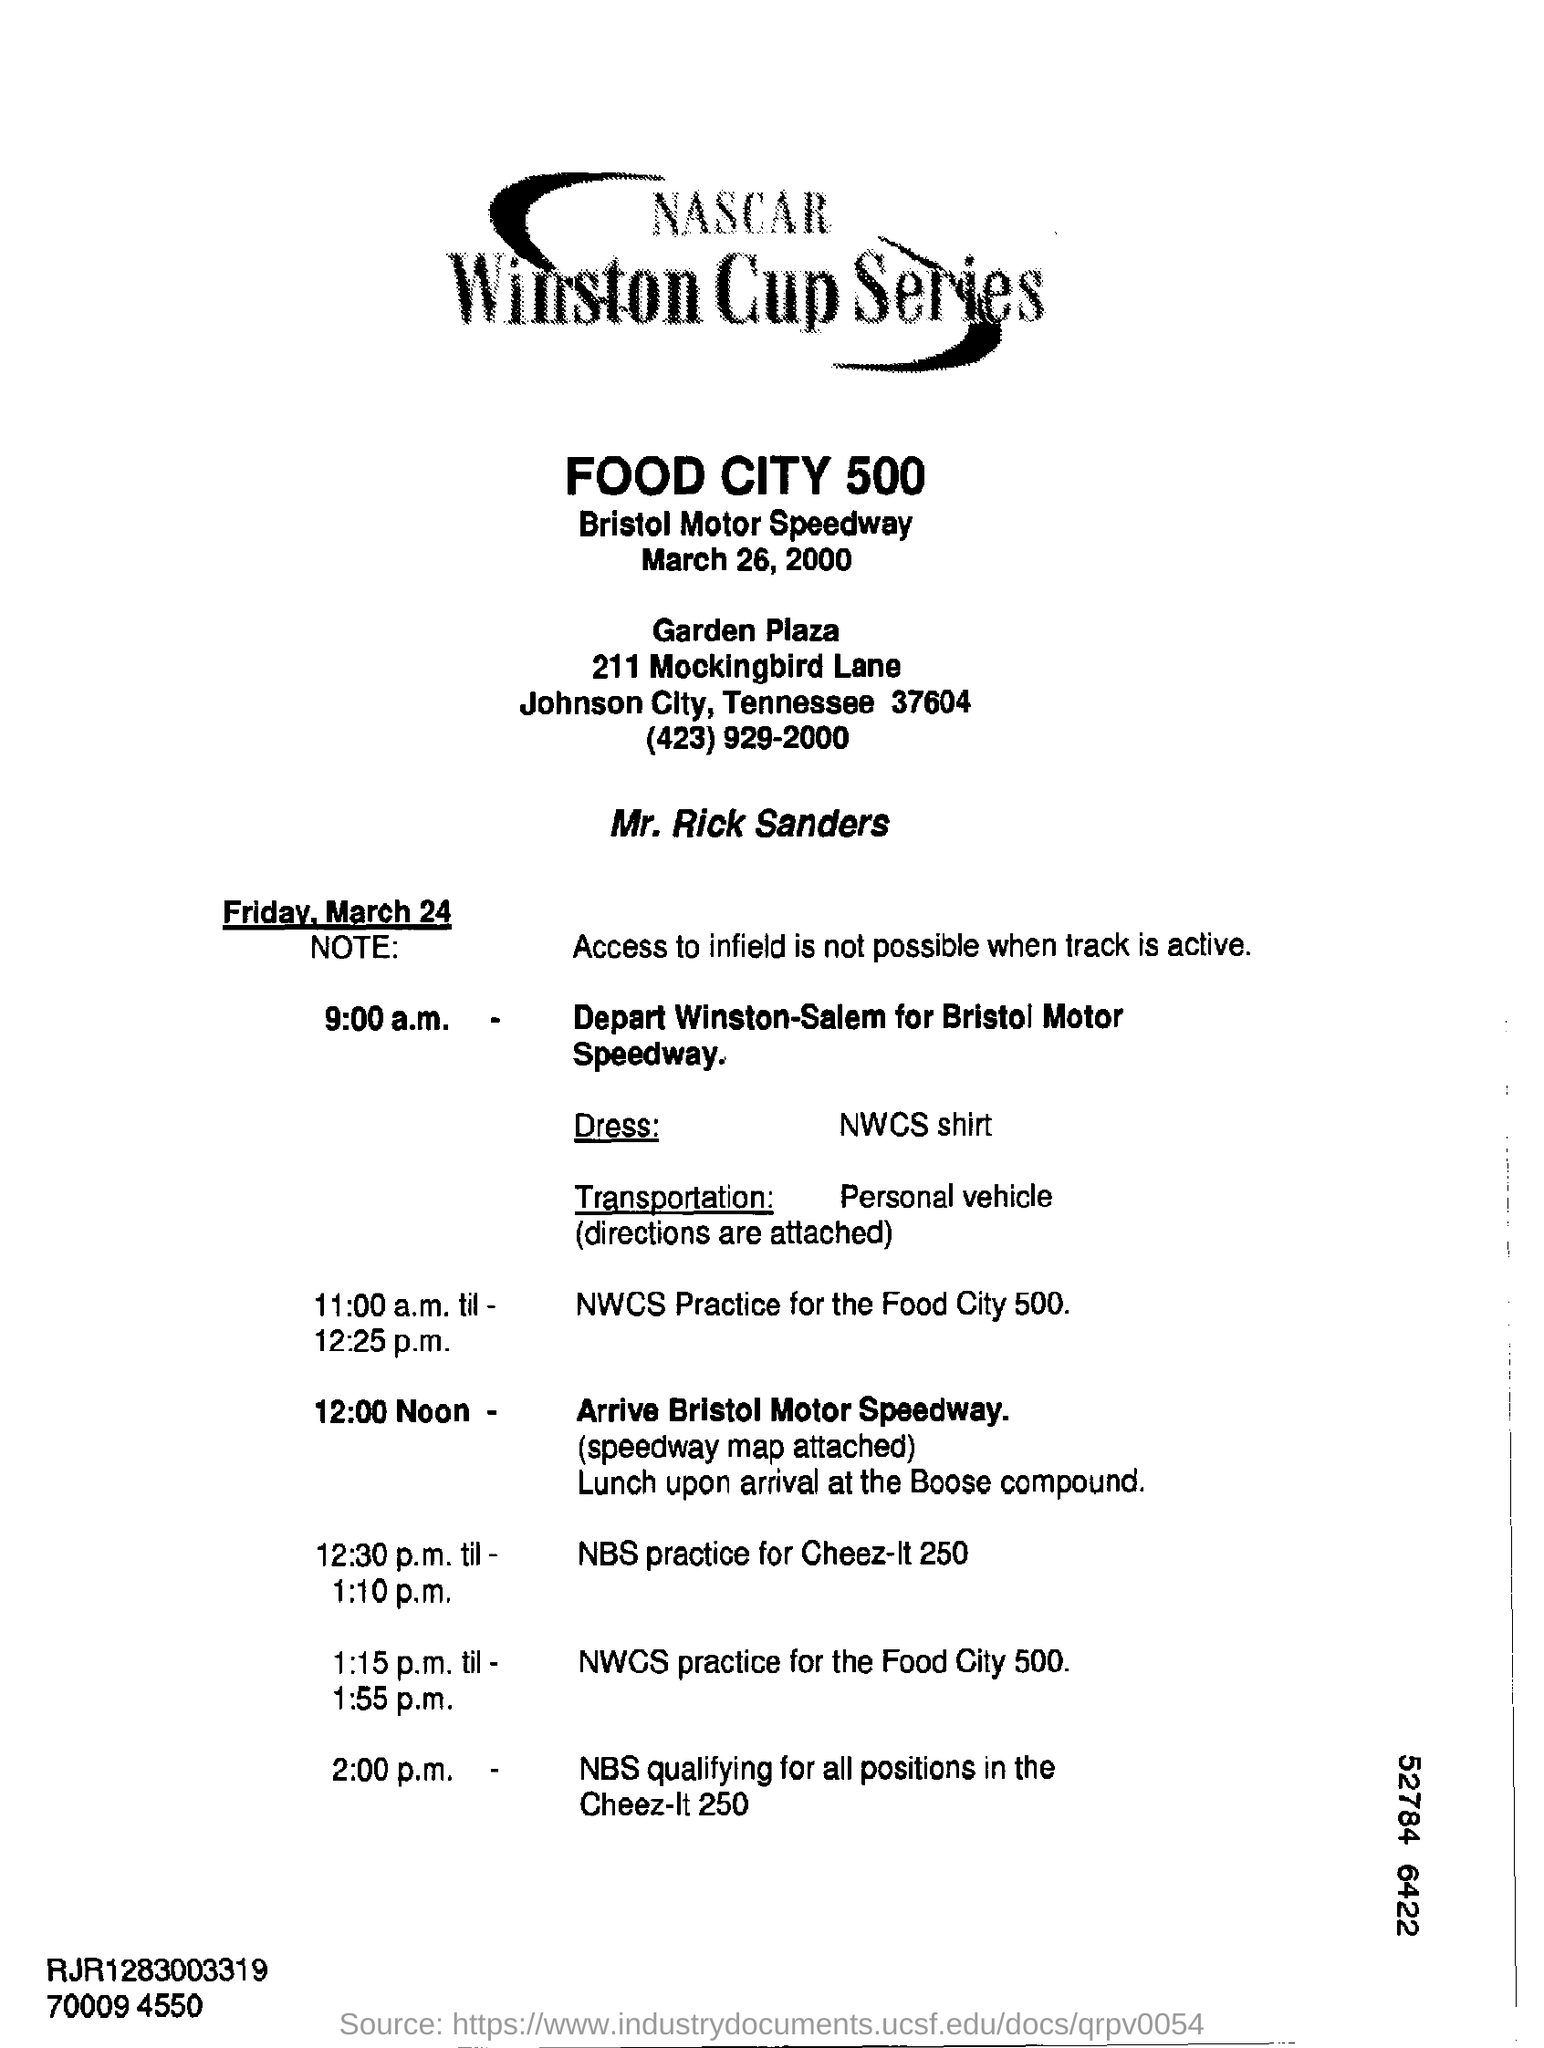What is the title of the given document?
Provide a short and direct response. NASCAR WINSTON CUP SERIES. 